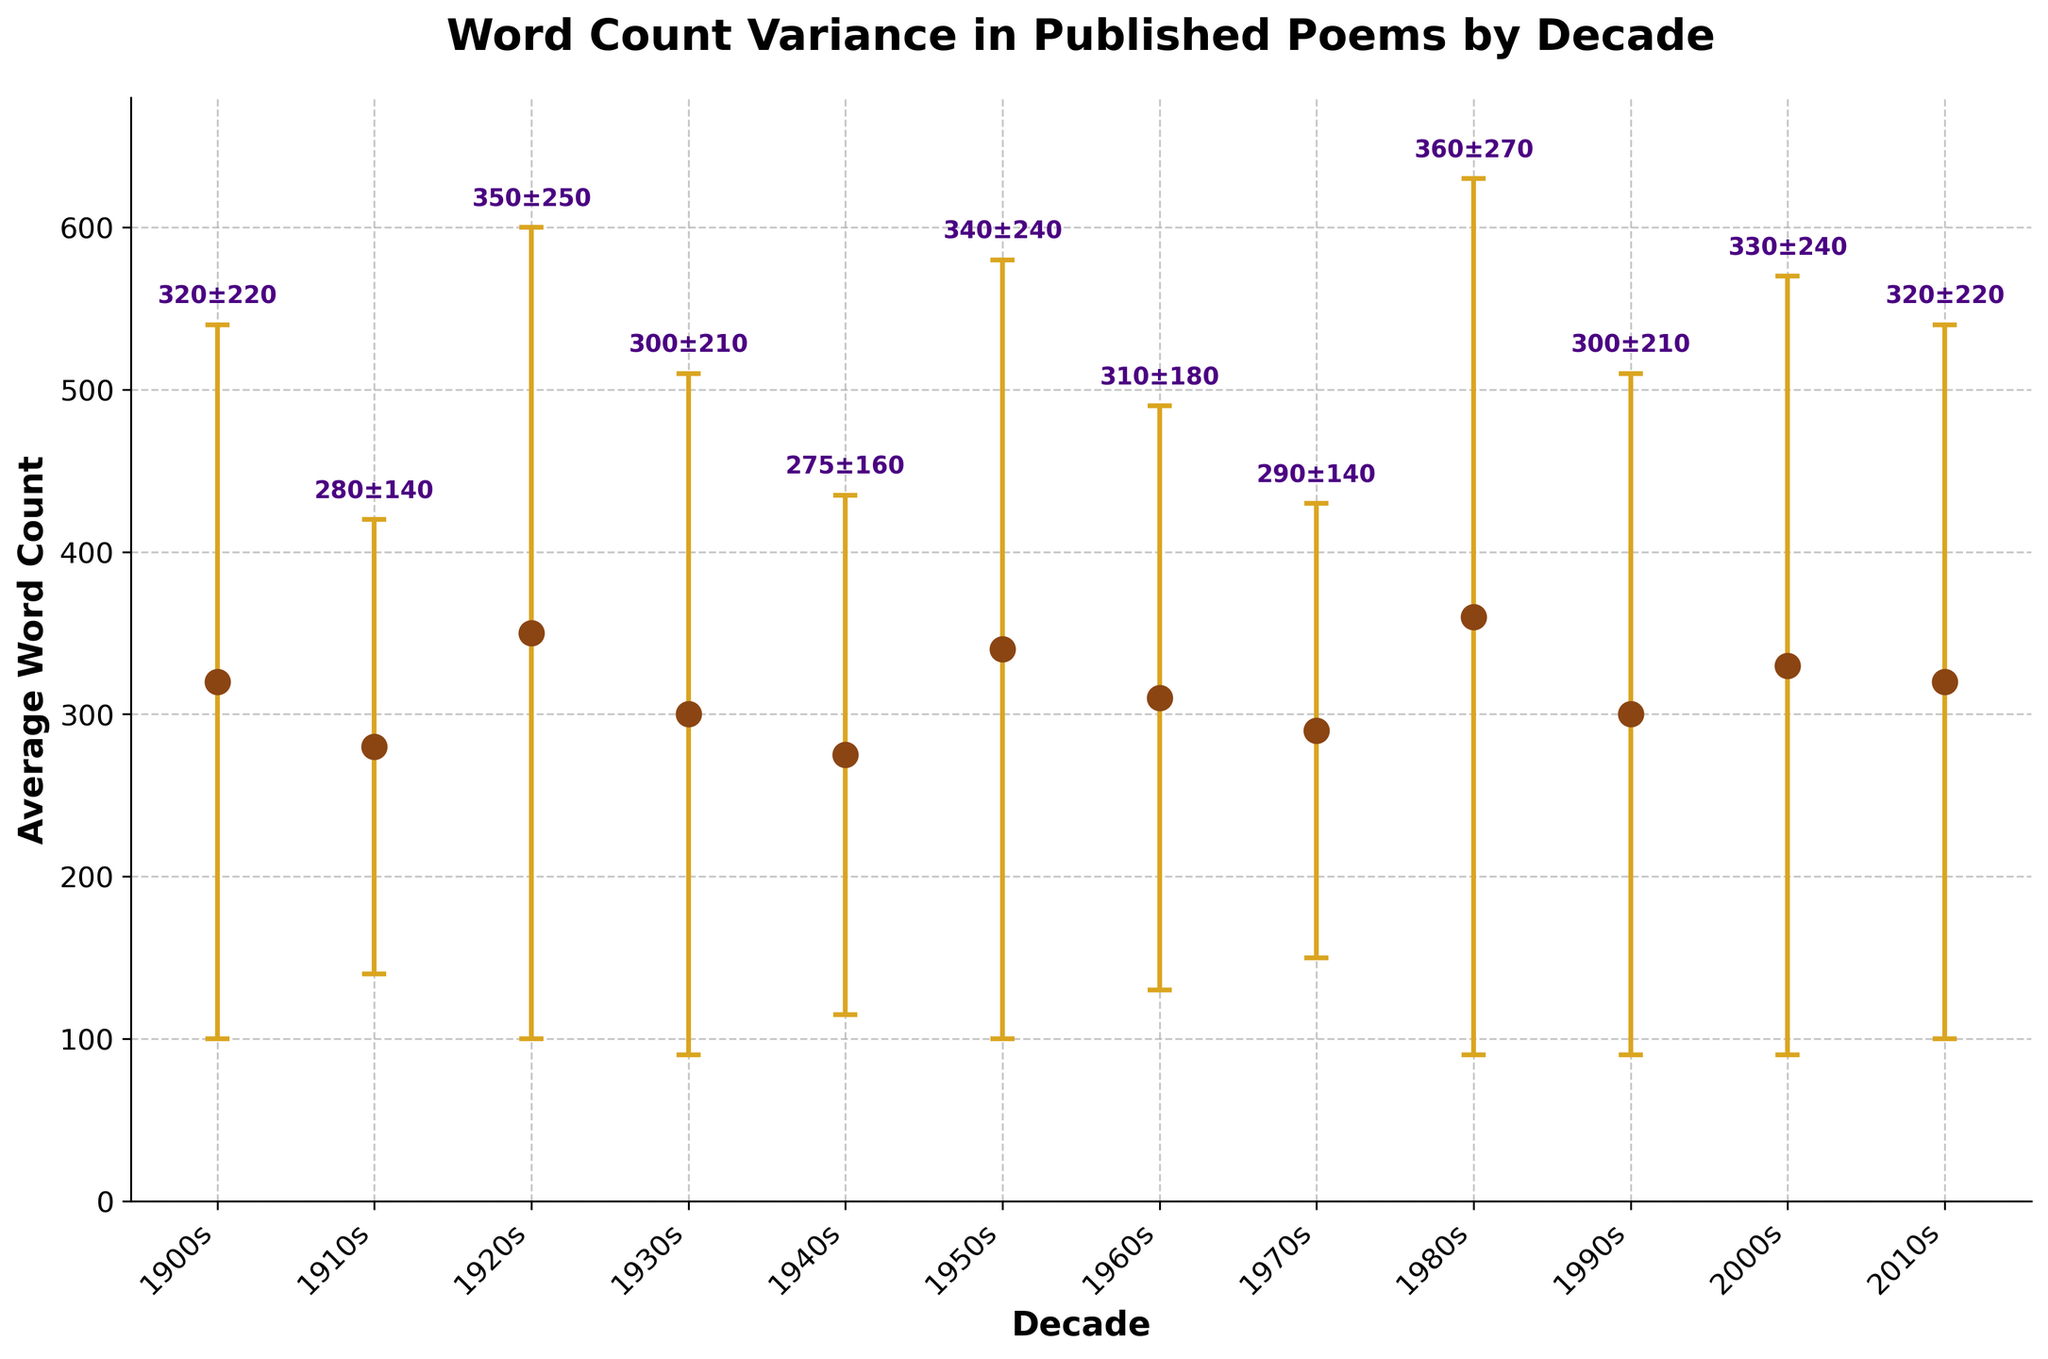What is the title of the plot? The title of the plot is usually placed at the top. In this case, the specific title stated is "Word Count Variance in Published Poems by Decade".
Answer: Word Count Variance in Published Poems by Decade What is the average word count of poems published in the 1920s? Looking at the corresponding data point marked on the plot for the 1920s along the x-axis, the average word count is indicated by the vertical position of the dot and the annotation near it.
Answer: 350 Which decade has the highest average word count in published poems? By observing the y-values of the data points, the decade with the highest average word count is identified by the dot positioned at the highest vertical point.
Answer: 1980s How many decades are represented in the plot? Count the number of distinct data points plotted along the x-axis which represent different decades.
Answer: 12 Which two decades have the same average word count? By examining the annotations or the vertical position of the dots, identify any two dots that share the same y-value.
Answer: 1900s and 2010s What is the average standard deviation of the word counts across all decades? Sum up all the standard deviation values provided on the plot and divide by the total number of decades. That is (220 + 140 + 250 + 210 + 160 + 240 + 180 + 140 + 270 + 210 + 240 + 220) / 12 = 218.33
Answer: 218.33 What is the difference in average word count between the 1940s and 1960s? Locate the average word counts for the 1940s and the 1960s (275 and 310, respectively), then calculate their difference: 310 - 275 = 35.
Answer: 35 Which decade shows the greatest variance in word count? The decade with the highest error bar (standard deviation) would have the highest variance as standard deviation is the square root of variance. Identify the largest error bar and read the corresponding decade.
Answer: 1980s What is the pattern of word count variance in published poems over time? Look at how the error bars change from decade to decade. Describe whether they generally increase, decrease, or show no consistent pattern.
Answer: The variance fluctuates, peaking in the 1980s and showing no clear increasing or decreasing trend Are there any decades where the word count variance is equal to the average word count? Compare the word count variance values to the respective average word count values. Specifically check 350 for the 1920s and 57600 for the 1950s since 350 and 57600 are quite far off from average word counts.
Answer: No 